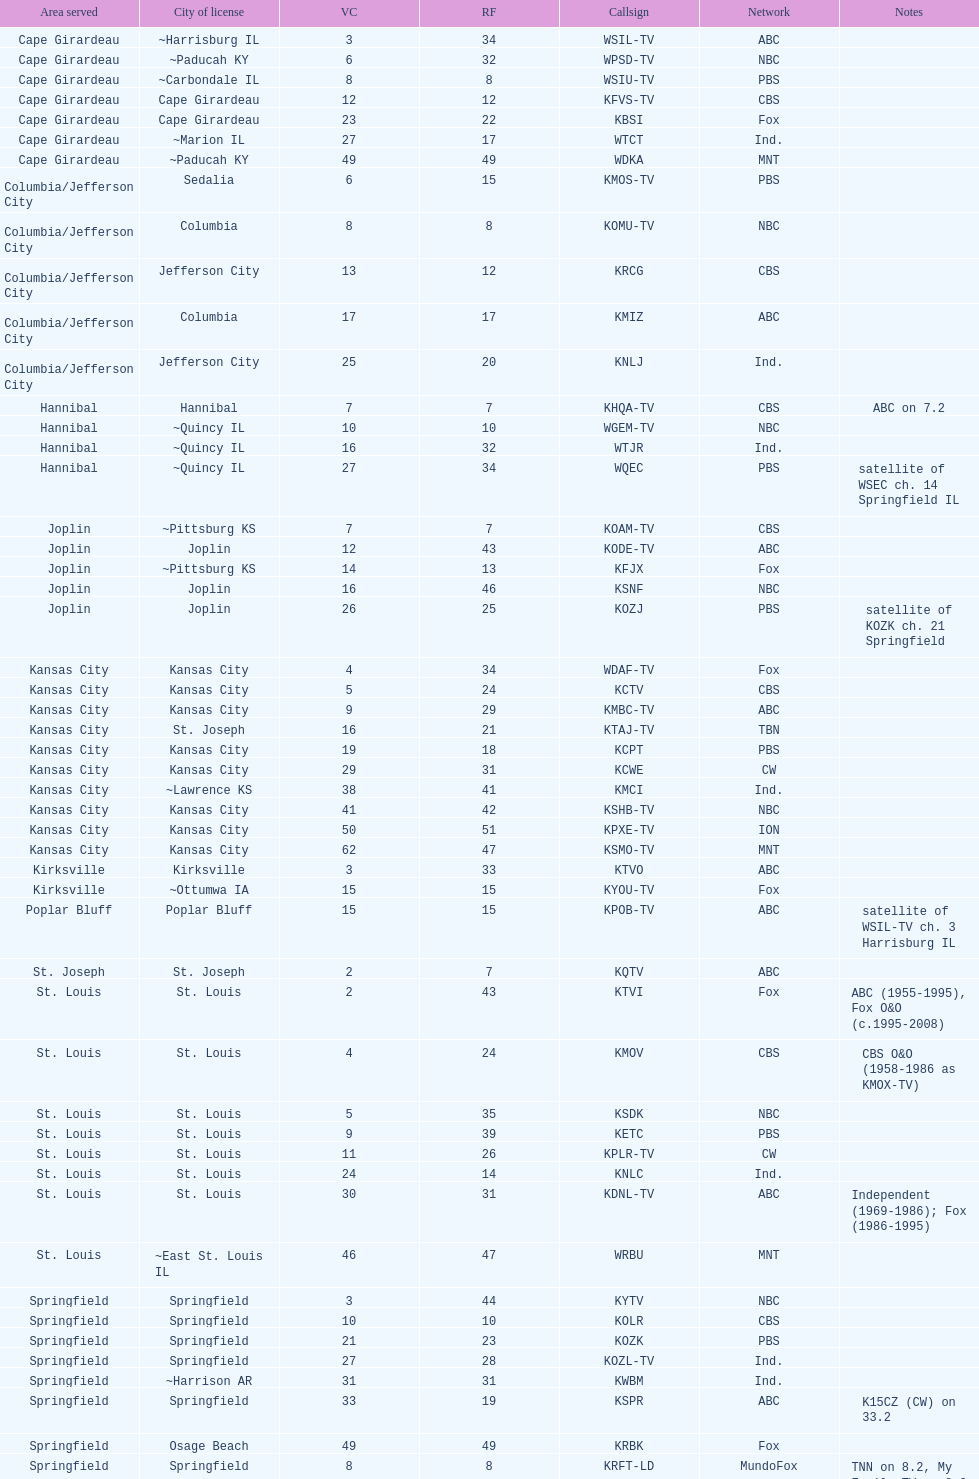How many cbs stations are there in total? 7. 